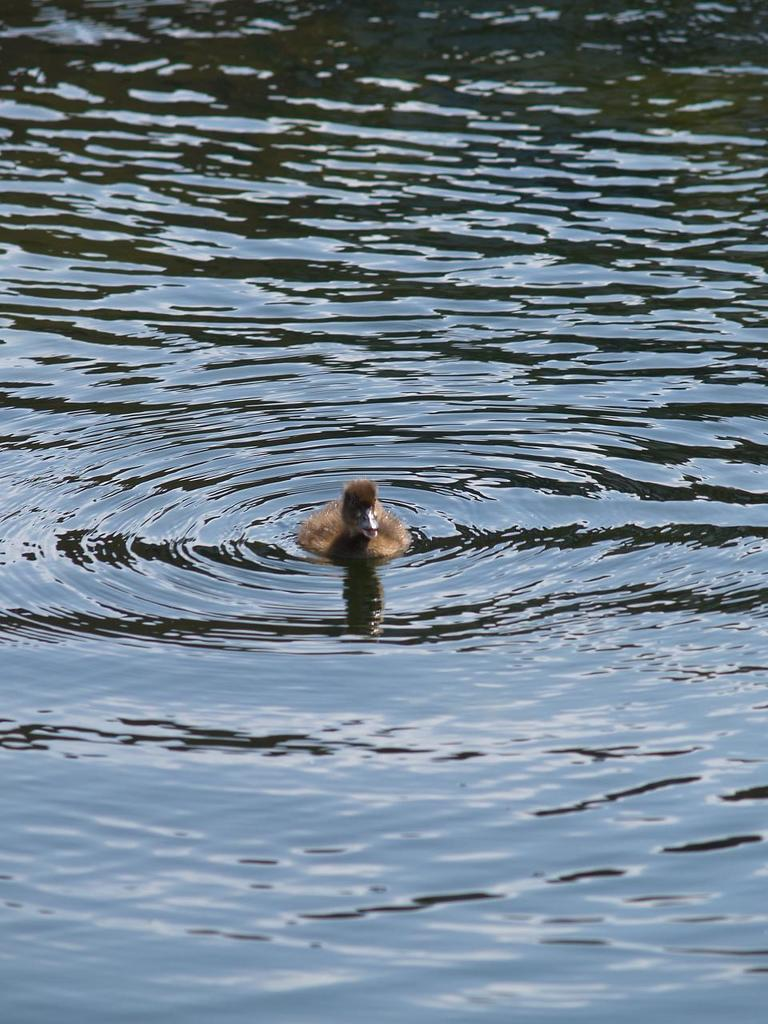What is the primary element visible in the image? There is water in the image. Can you describe any living organisms present in the image? There is a brown-colored bird in the water. How many fingers can be seen on the bird in the image? Birds do not have fingers, so there are no fingers visible on the bird in the image. What type of truck is driving through the water in the image? There is no truck present in the image; it only features water and a brown-colored bird. 